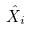Convert formula to latex. <formula><loc_0><loc_0><loc_500><loc_500>\hat { X } _ { i }</formula> 